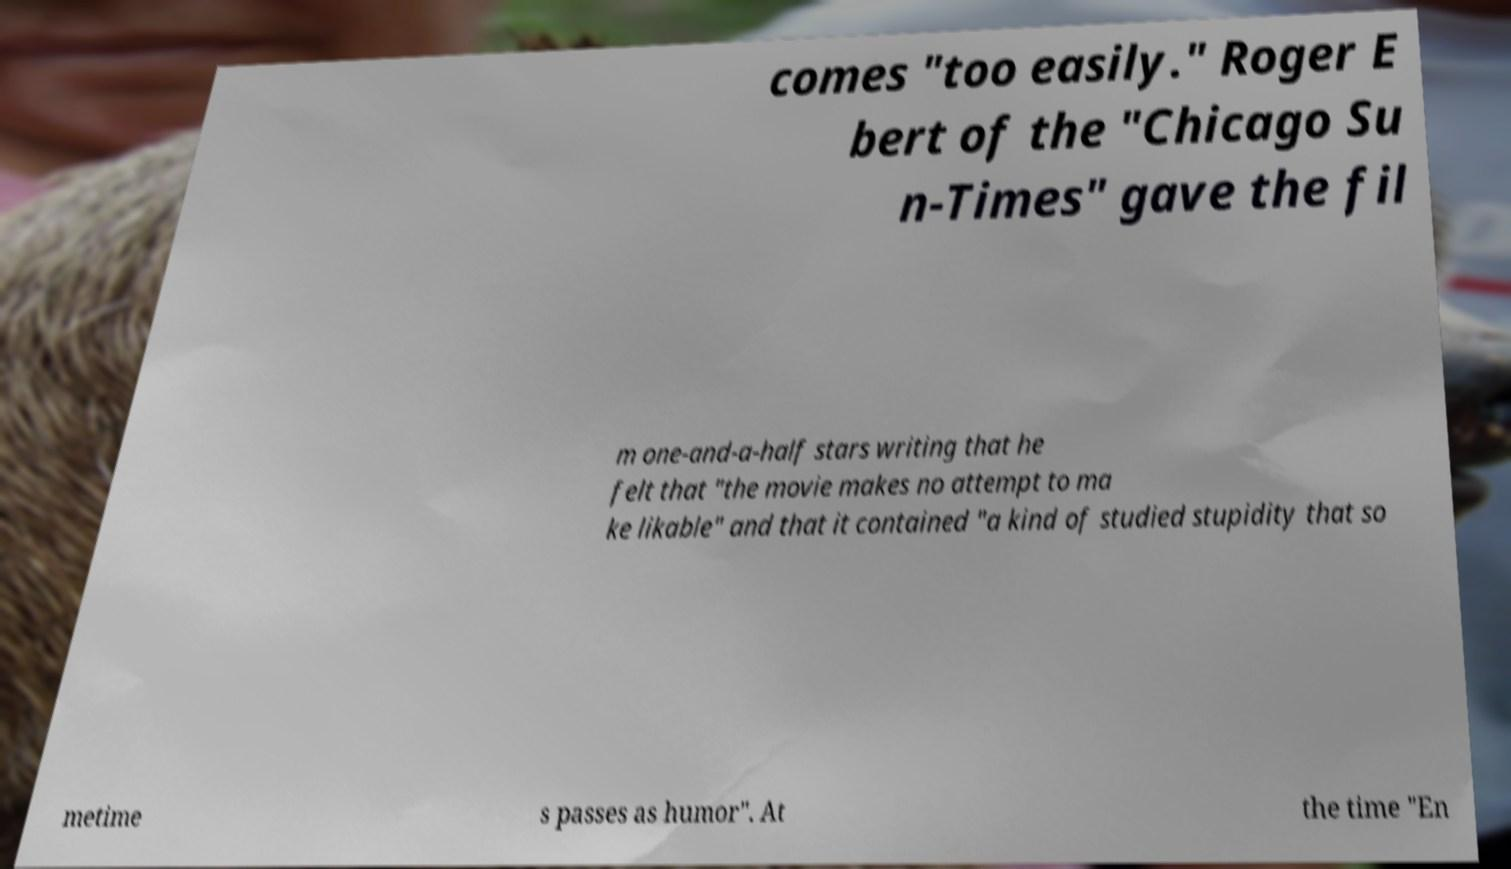Could you assist in decoding the text presented in this image and type it out clearly? comes "too easily." Roger E bert of the "Chicago Su n-Times" gave the fil m one-and-a-half stars writing that he felt that "the movie makes no attempt to ma ke likable" and that it contained "a kind of studied stupidity that so metime s passes as humor". At the time "En 